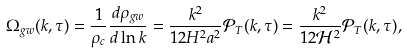Convert formula to latex. <formula><loc_0><loc_0><loc_500><loc_500>\Omega _ { g w } ( k , \tau ) = \frac { 1 } { \rho _ { c } } \frac { d \rho _ { g w } } { d \ln { k } } = \frac { k ^ { 2 } } { 1 2 H ^ { 2 } a ^ { 2 } } { \mathcal { P } } _ { T } ( k , \tau ) = \frac { k ^ { 2 } } { 1 2 { \mathcal { H } } ^ { 2 } } { \mathcal { P } } _ { T } ( k , \tau ) ,</formula> 